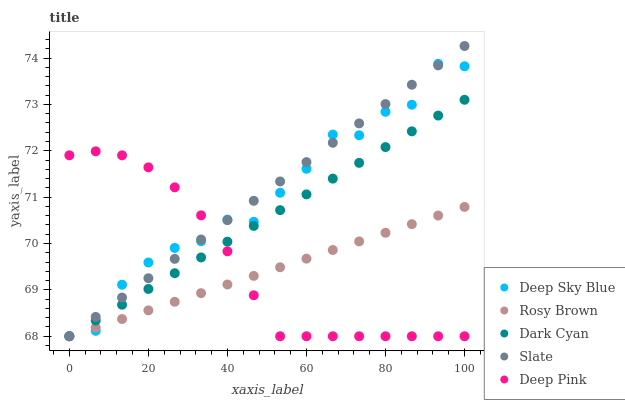Does Rosy Brown have the minimum area under the curve?
Answer yes or no. Yes. Does Slate have the maximum area under the curve?
Answer yes or no. Yes. Does Slate have the minimum area under the curve?
Answer yes or no. No. Does Rosy Brown have the maximum area under the curve?
Answer yes or no. No. Is Rosy Brown the smoothest?
Answer yes or no. Yes. Is Deep Sky Blue the roughest?
Answer yes or no. Yes. Is Slate the smoothest?
Answer yes or no. No. Is Slate the roughest?
Answer yes or no. No. Does Dark Cyan have the lowest value?
Answer yes or no. Yes. Does Slate have the highest value?
Answer yes or no. Yes. Does Rosy Brown have the highest value?
Answer yes or no. No. Does Deep Sky Blue intersect Slate?
Answer yes or no. Yes. Is Deep Sky Blue less than Slate?
Answer yes or no. No. Is Deep Sky Blue greater than Slate?
Answer yes or no. No. 